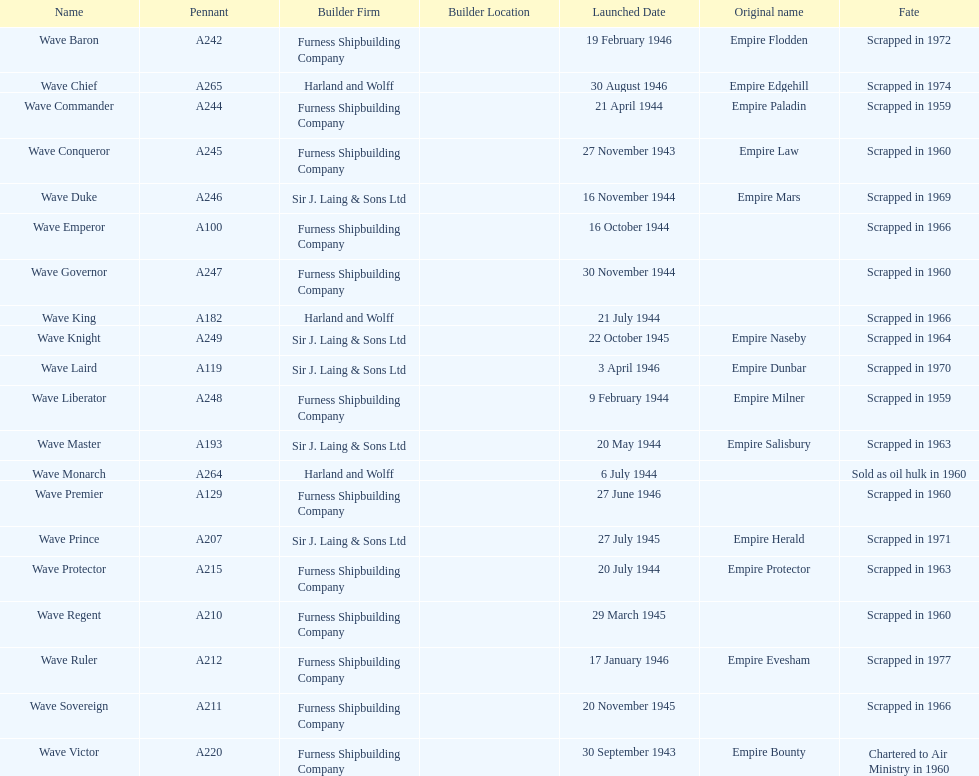What was the next wave class oiler after wave emperor? Wave Duke. 